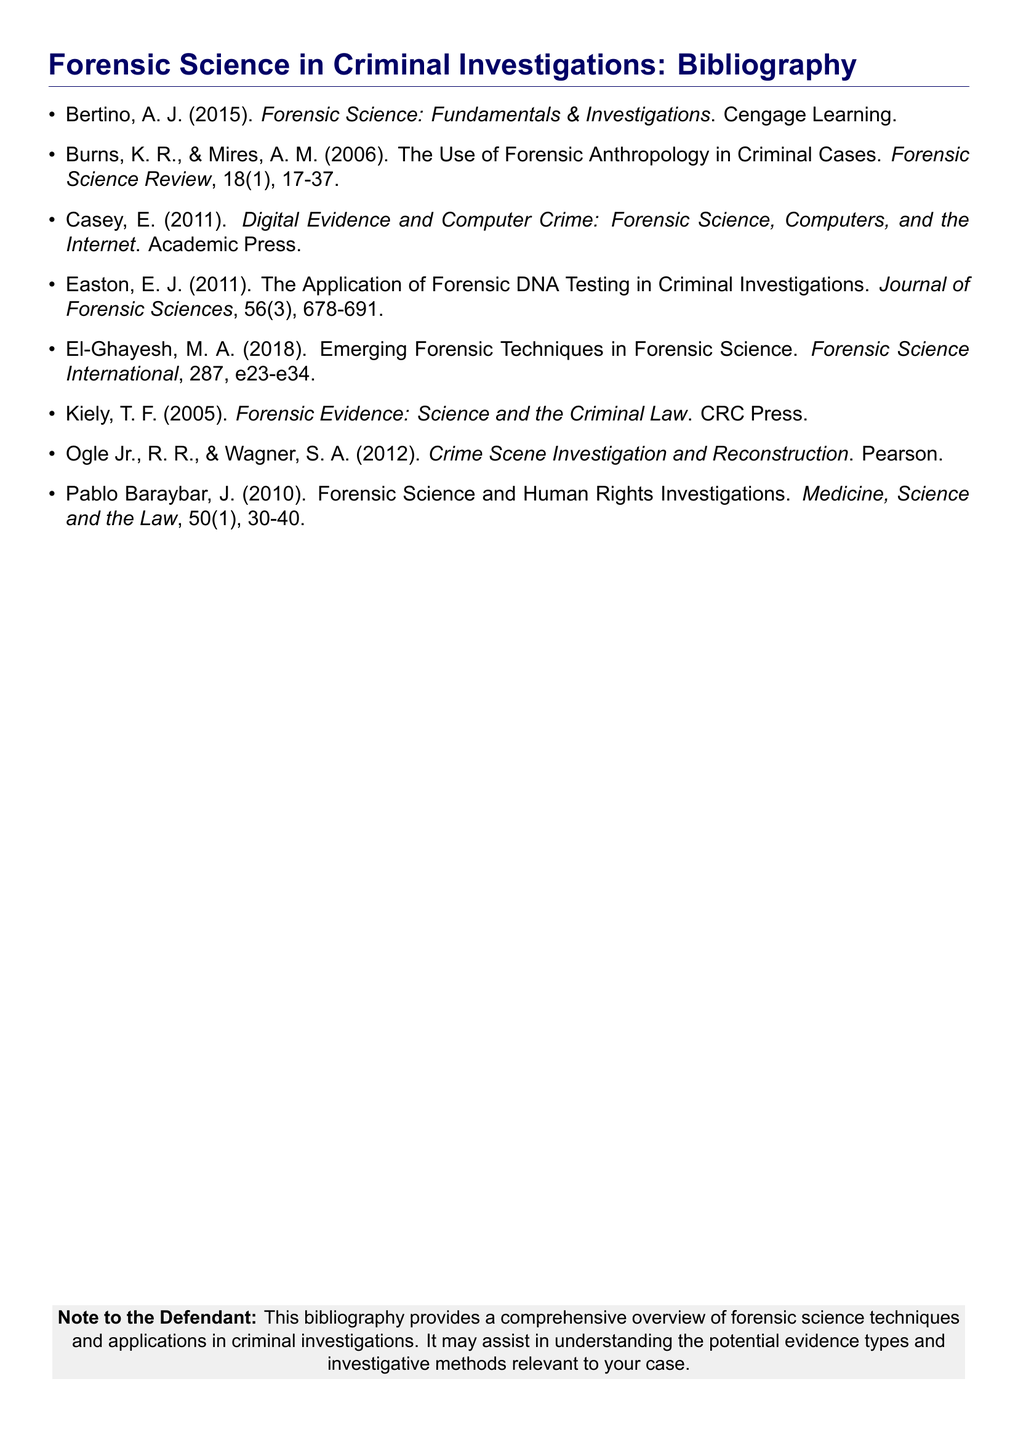What is the title of the first listed work? The title of the first listed work is the full title provided at the top of the bibliography, which is critical for referencing.
Answer: Forensic Science: Fundamentals & Investigations Who are the authors of the second work? The authors of the second work need to be identified, as they contribute to the field of forensic science.
Answer: Burns, K. R. & Mires, A. M What year was the work by Kiely published? The year of publication is essential for understanding the relevance and timeliness of the research presented.
Answer: 2005 How many works are listed in this bibliography? Understanding the number of works helps to gauge the breadth of resources available on the topic.
Answer: 8 What journal published the work on forensic DNA testing? The journal provides context and credibility to the work discussed in the bibliography.
Answer: Journal of Forensic Sciences Which author wrote about Forensic Science and Human Rights? Identifying this author can provide insights into the ranges of applications discussed in forensic science.
Answer: Pablo Baraybar, J What is the subject of the work by El-Ghayesh? Determining the subject of a work can help in understanding the advancements and techniques in forensic science highlighted in the bibliography.
Answer: Emerging Forensic Techniques Which publisher released the book by Casey? Knowing the publisher may give clues about the book's intended audience, academic rigor, and focus.
Answer: Academic Press 